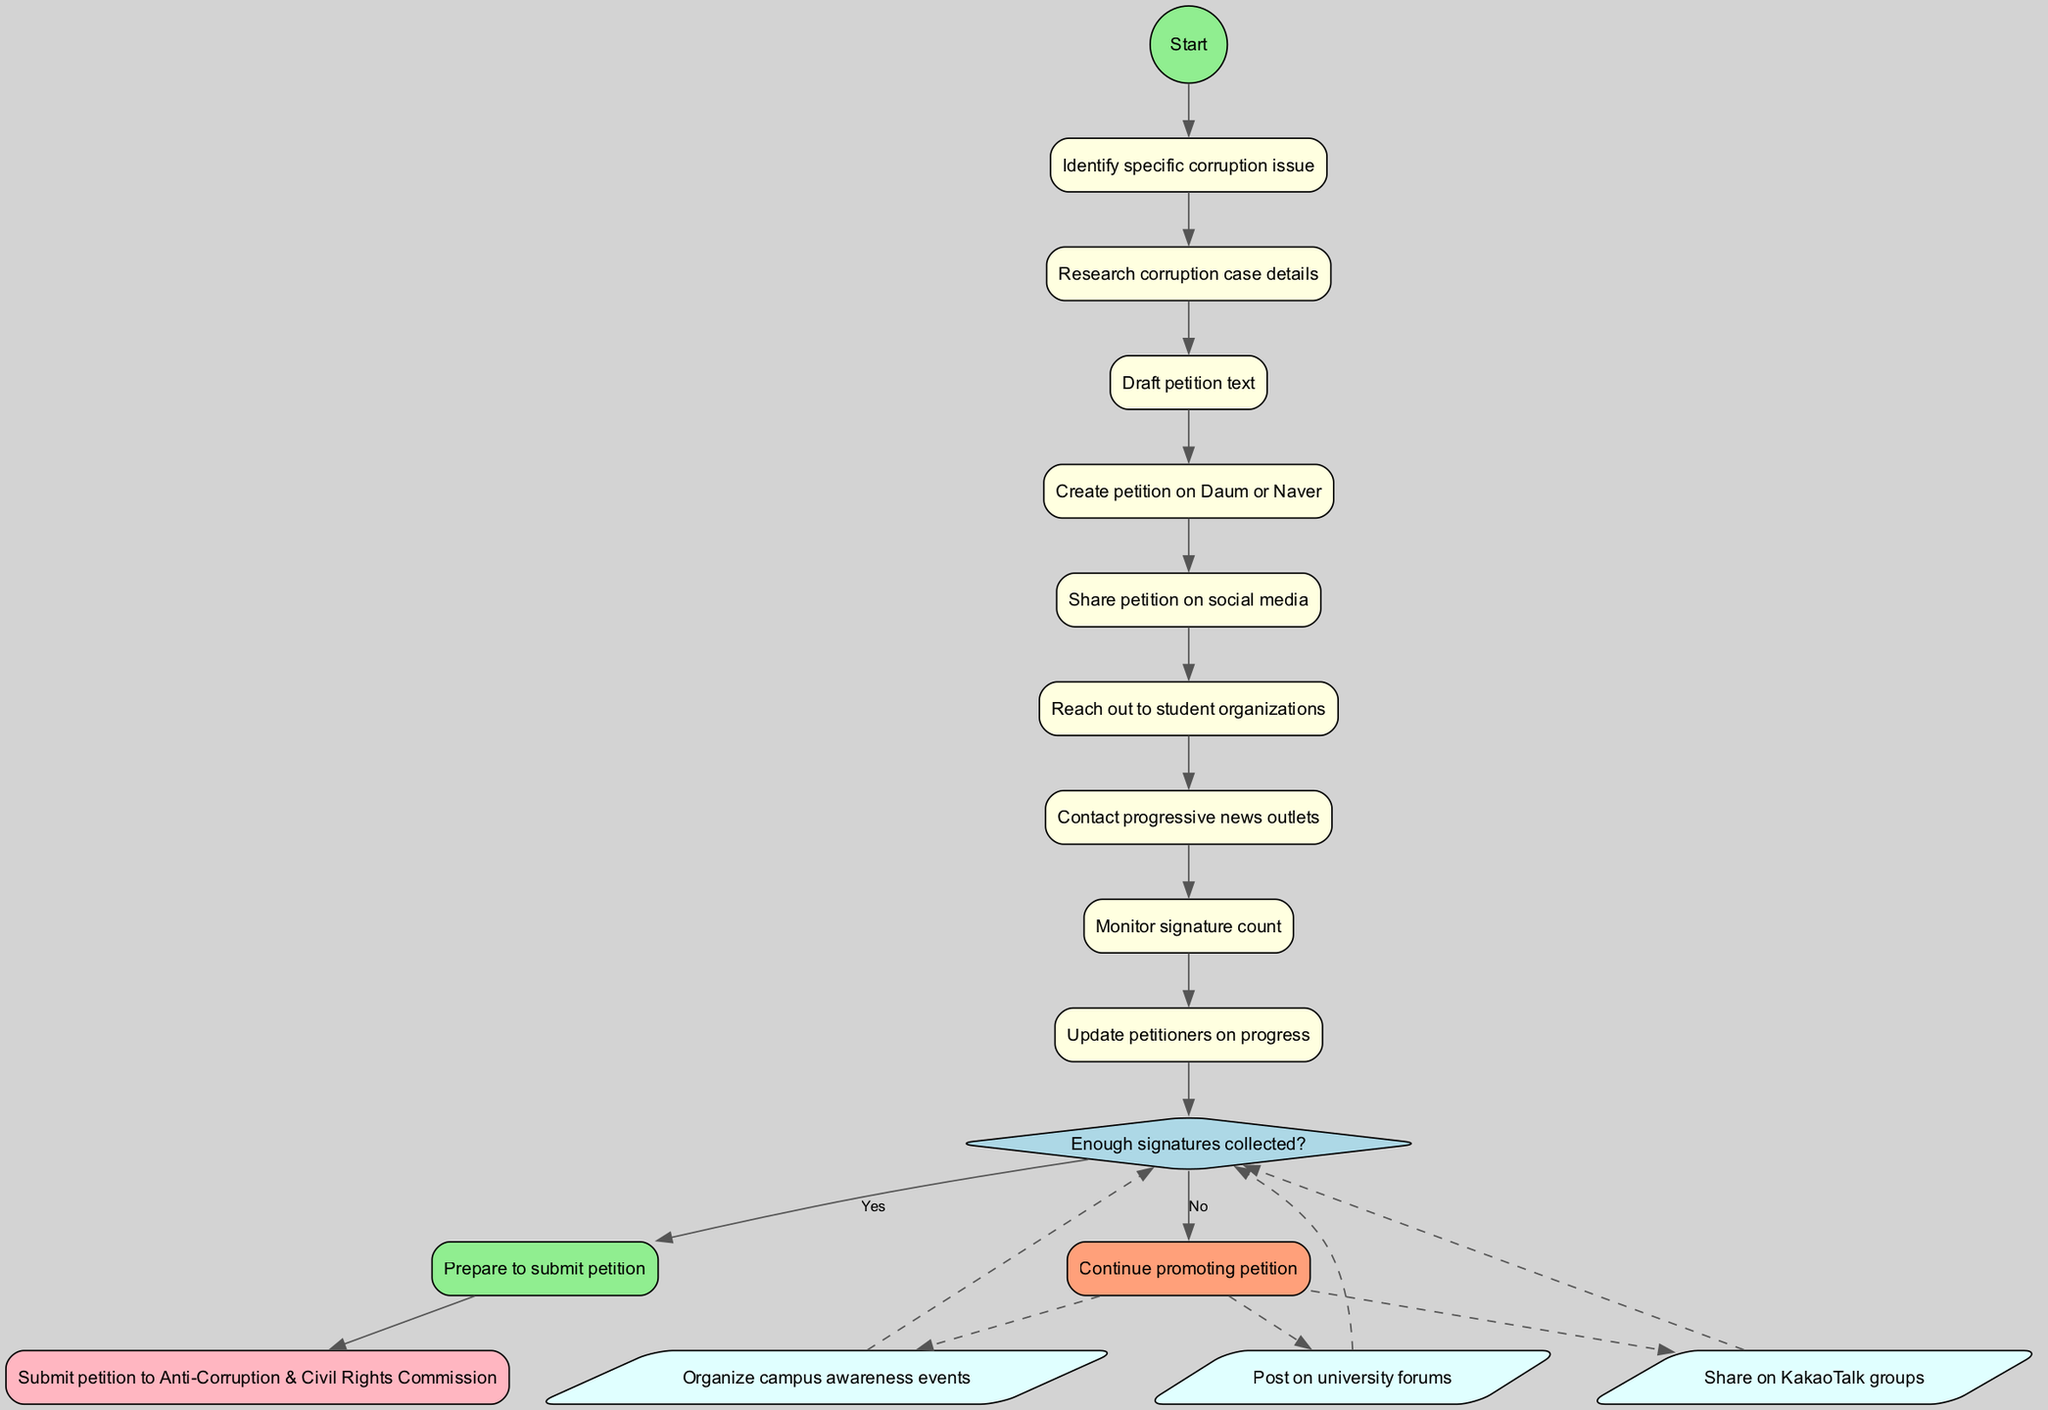What is the starting point of the activity diagram? The starting point of the diagram is "Identify specific corruption issue," which is indicated right after the start node.
Answer: Identify specific corruption issue How many activities are listed in the diagram? The diagram lists eight activities in total, as seen in the activities section of the flow.
Answer: 8 What is the decision point in the diagram? The decision point in the diagram is labeled "Enough signatures collected?" which represents determining the next steps based on whether the signature count meets a threshold.
Answer: Enough signatures collected? What happens if there are not enough signatures? If there are not enough signatures, the designated action is "Continue promoting petition," which leads to further attempts to gather signatures before potentially resuming the flow.
Answer: Continue promoting petition What is the final action taken in the process? The final action taken is "Submit petition to Anti-Corruption & Civil Rights Commission," which concludes the flow of the activity diagram.
Answer: Submit petition to Anti-Corruption & Civil Rights Commission Which nodes lead to the decision point? The node preceding the decision point is "Monitor signature count," which directly connects to the decision node to assess the progress of signature collection.
Answer: Monitor signature count What are the additional methods of promoting the petition? The diagram includes three additional methods for promoting the petition: sharing on KakaoTalk groups, posting on university forums, and organizing campus awareness events.
Answer: Organize campus awareness events Describe the relationship between the "Yes" outcome and the end node. The "Yes" outcome indicates that enough signatures have been collected, leading directly to the end node where the petition can be submitted, showing a successful completion of the process.
Answer: Submit petition to Anti-Corruption & Civil Rights Commission What style is applied to the nodes in the diagram? The nodes in the diagram are styled as rectangles with rounded edges and filled color, indicated by the attributes assigned in the diagram creation process.
Answer: Rounded edges, filled color 